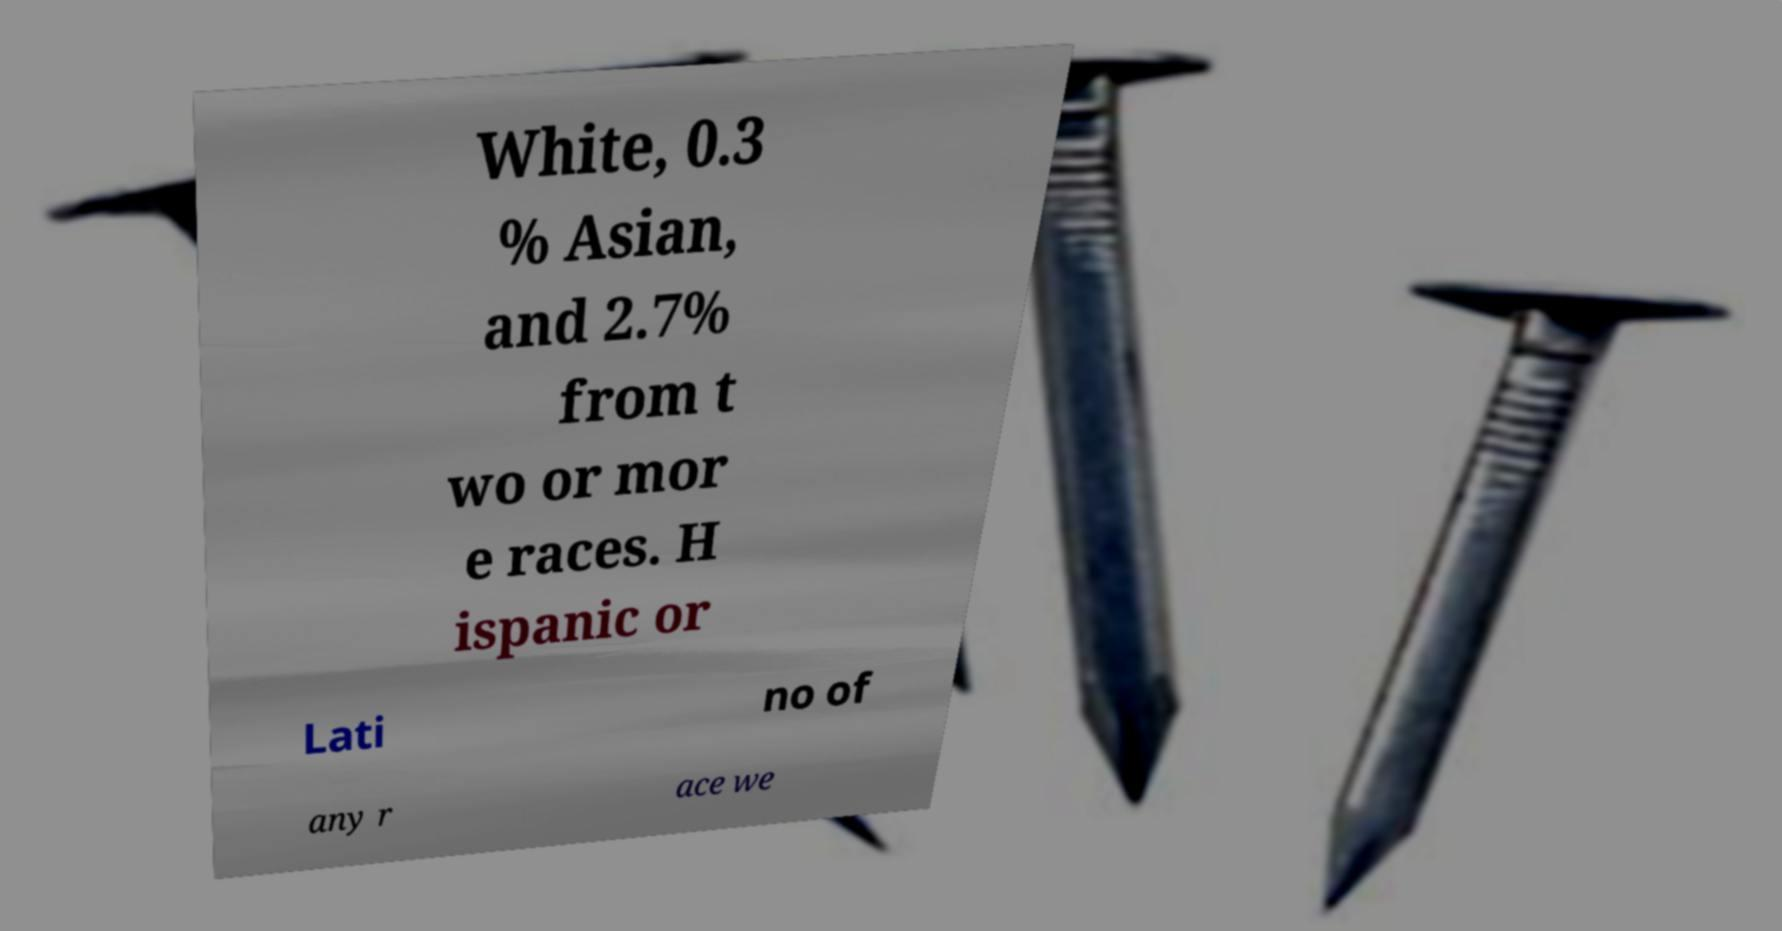Could you extract and type out the text from this image? White, 0.3 % Asian, and 2.7% from t wo or mor e races. H ispanic or Lati no of any r ace we 